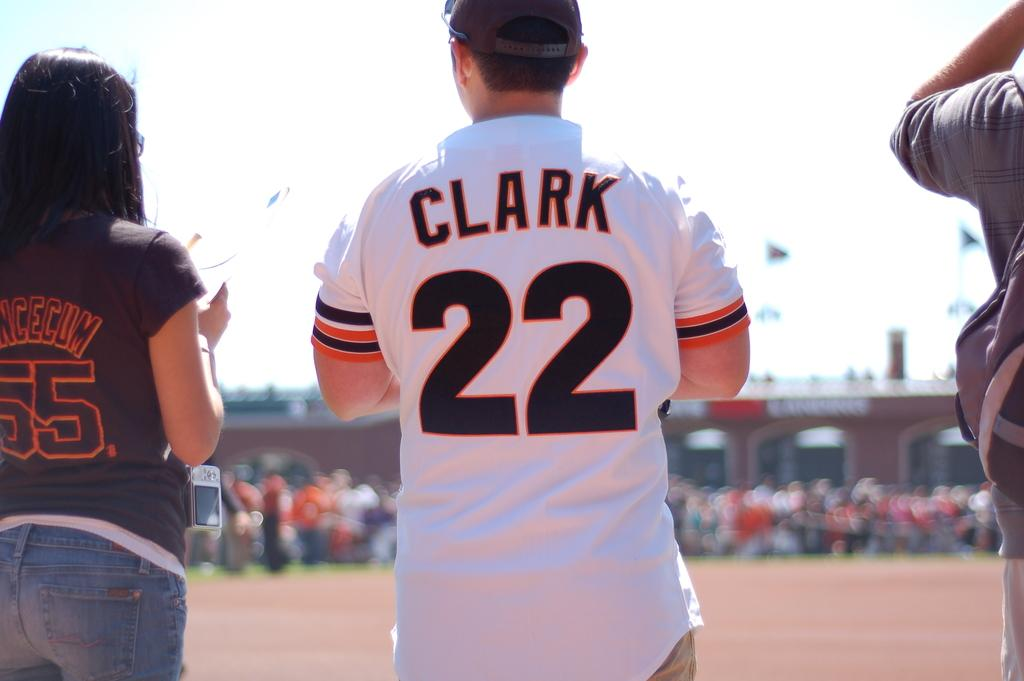<image>
Describe the image concisely. A person wearing a jersey with the number 55 stands to the left of someone wearing a jersey with the number 22. 